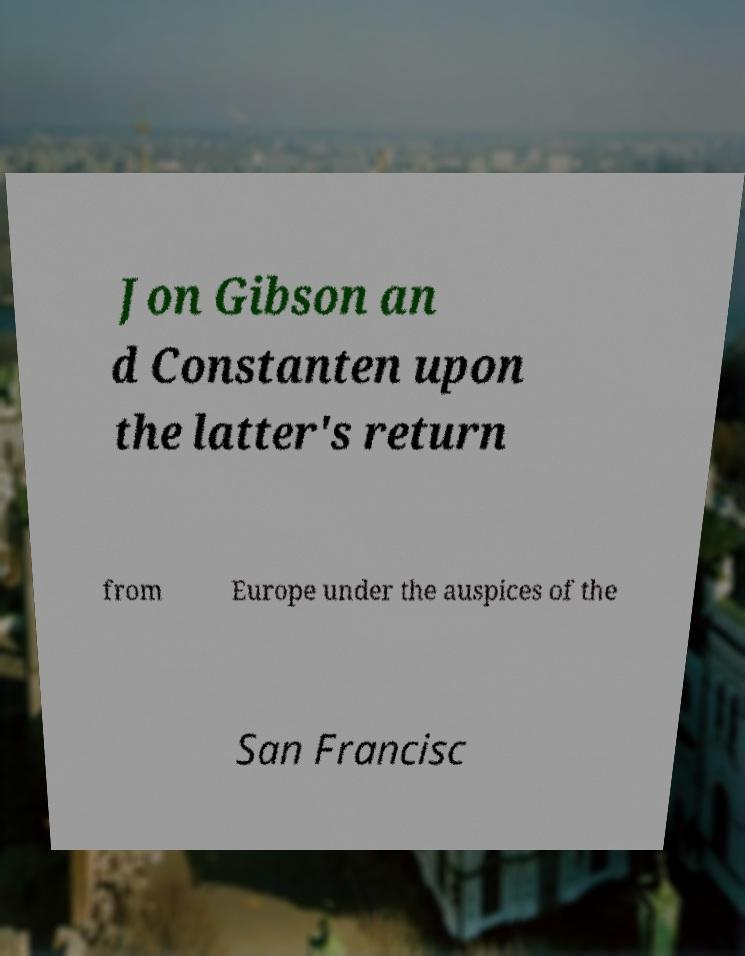For documentation purposes, I need the text within this image transcribed. Could you provide that? Jon Gibson an d Constanten upon the latter's return from Europe under the auspices of the San Francisc 